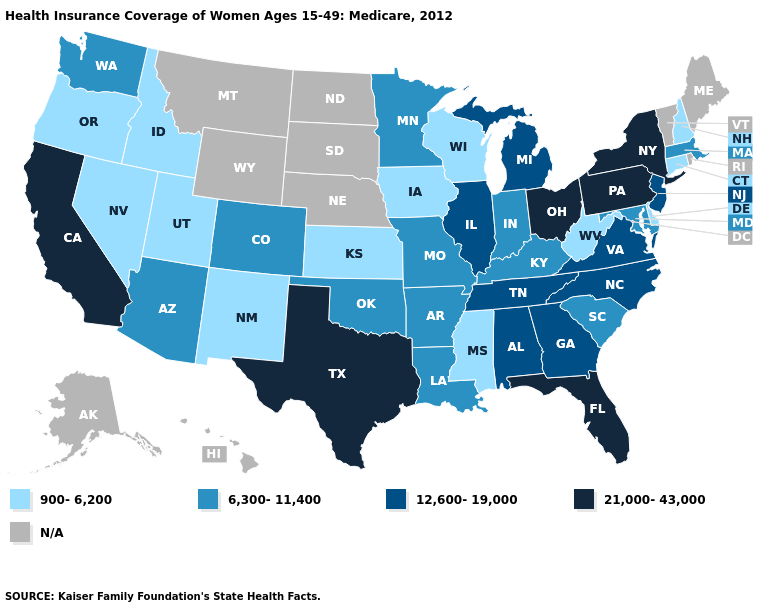What is the value of Connecticut?
Quick response, please. 900-6,200. Among the states that border Colorado , which have the lowest value?
Keep it brief. Kansas, New Mexico, Utah. Does the map have missing data?
Answer briefly. Yes. What is the highest value in the USA?
Quick response, please. 21,000-43,000. Which states have the highest value in the USA?
Short answer required. California, Florida, New York, Ohio, Pennsylvania, Texas. Name the states that have a value in the range 12,600-19,000?
Answer briefly. Alabama, Georgia, Illinois, Michigan, New Jersey, North Carolina, Tennessee, Virginia. What is the highest value in states that border Virginia?
Keep it brief. 12,600-19,000. Name the states that have a value in the range 900-6,200?
Concise answer only. Connecticut, Delaware, Idaho, Iowa, Kansas, Mississippi, Nevada, New Hampshire, New Mexico, Oregon, Utah, West Virginia, Wisconsin. Does Ohio have the highest value in the MidWest?
Be succinct. Yes. What is the value of Maryland?
Be succinct. 6,300-11,400. What is the value of Nevada?
Quick response, please. 900-6,200. 